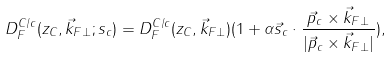<formula> <loc_0><loc_0><loc_500><loc_500>D _ { F } ^ { C / c } ( z _ { C } , \vec { k } _ { F \perp } ; s _ { c } ) = D _ { F } ^ { C / c } ( z _ { C } , \vec { k } _ { F \perp } ) ( 1 + \alpha \vec { s } _ { c } \cdot { \frac { \vec { p } _ { c } \times \vec { k } _ { F \perp } } { | \vec { p } _ { c } \times \vec { k } _ { F \perp } | } } ) ,</formula> 